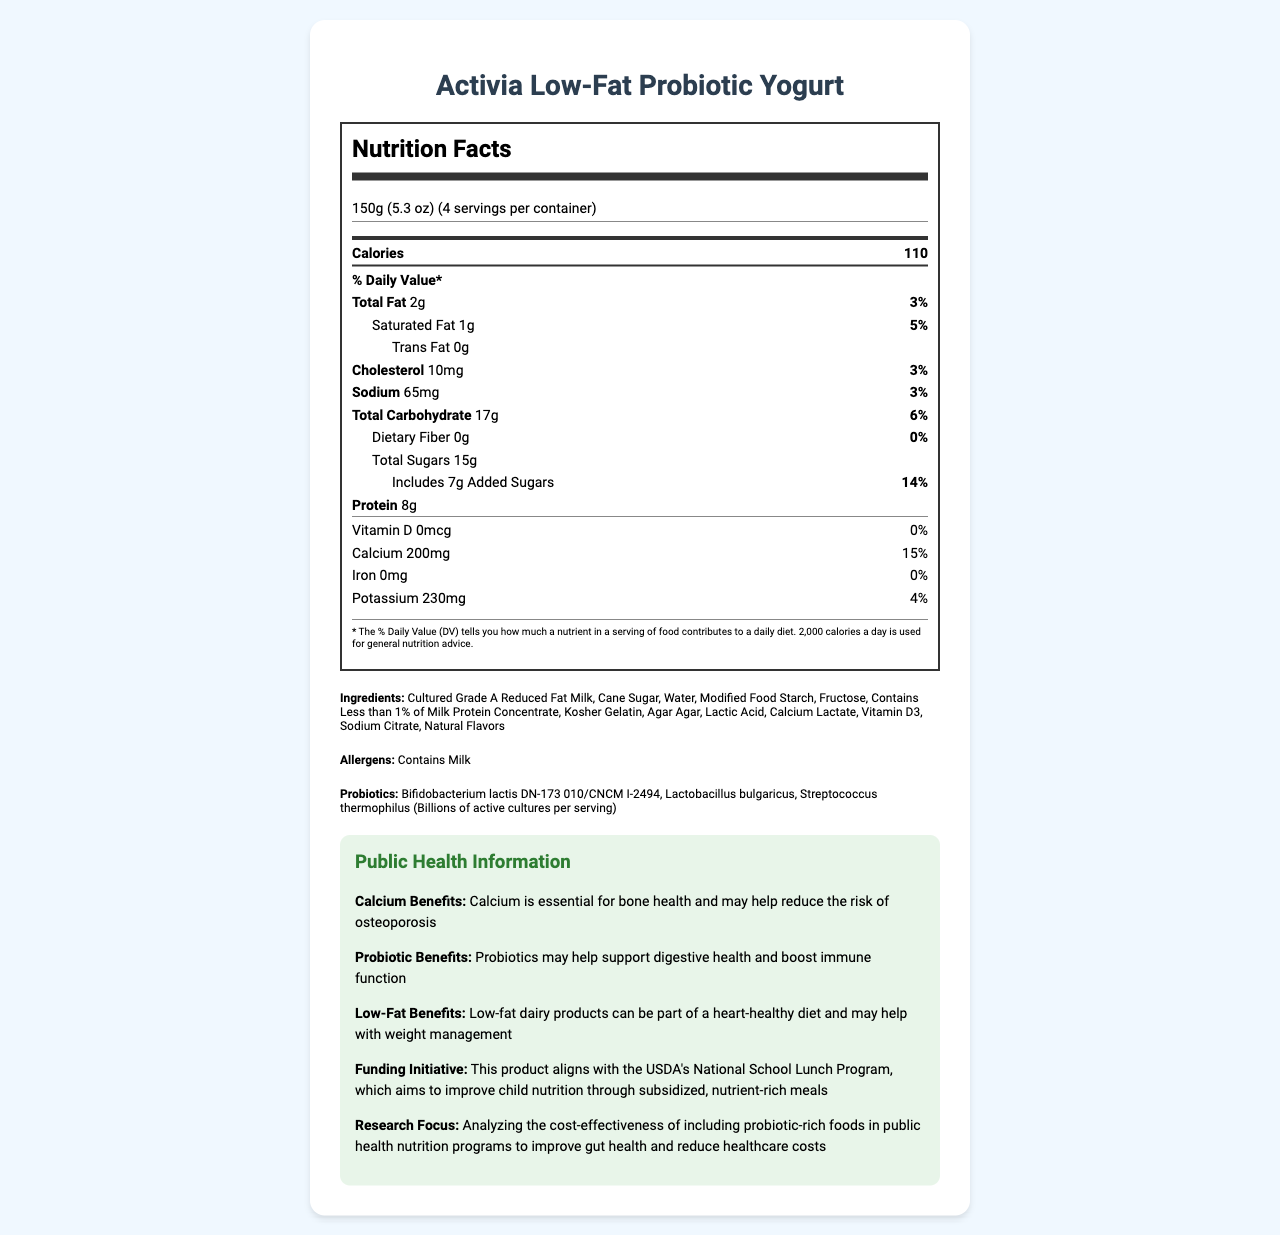what is the serving size for Activia Low-Fat Probiotic Yogurt? The serving size is explicitly mentioned under the serving information at the top of the document.
Answer: 150g (5.3 oz) how many servings are there per container? The document states that there are 4 servings per container at the top under the product name.
Answer: 4 how much calcium is there in a serving of the yogurt? The calcium content is found in the nutrient table under the “Calcium” row.
Answer: 200mg what percentage of the daily value is the added sugars? The percentage of added sugars is listed in the nutrient table under “Includes 7g Added Sugars.”
Answer: 14% list the probiotics contained in this yogurt. These strains are listed under the "Ingredients" section of the document.
Answer: Bifidobacterium lactis DN-173 010/CNCM I-2494, Lactobacillus bulgaricus, Streptococcus thermophilus which of the following best describes the primary health benefits of the probiotics in the yogurt? A. Improve bone health B. Support digestive health C. Enhance muscle growth The document states that probiotics may help support digestive health and boost immune function.
Answer: B how many calories are in a single serving? A. 90 B. 110 C. 120 D. 130 The calories in a single serving are clearly listed as 110 in the nutrient table.
Answer: B is there any iron in this yogurt? The document states that both the iron amount and the percent daily value are 0%.
Answer: No summarize the main points of the document. The document includes detailed nutrition information, a list of ingredients and allergens, and public health benefits related to calcium, low fat, and probiotics. Additionally, it contains information on a funding initiative and research focus.
Answer: This document provides the nutrition facts for Activia Low-Fat Probiotic Yogurt, emphasizing its low fat and probiotic content. The yogurt contains key nutrients such as protein and calcium, along with beneficial probiotics. It also aligns with public health initiatives like the USDA's National School Lunch Program and aims to promote digestive health while being a heart-healthy, low-fat option. what is the total amount of sugars in a single serving of the yogurt? The total amount of sugars is listed as 15g in the nutrient table under “Total Sugars.”
Answer: 15g how many grams of protein does each serving of yogurt contain? The protein content per serving is listed as 8g in the nutrient table.
Answer: 8g what is the research focus related to this product? The research focus is explicitly mentioned under the public health information section.
Answer: Analyzing the cost-effectiveness of including probiotic-rich foods in public health nutrition programs to improve gut health and reduce healthcare costs. can this document tell you the cost of Activia Low-Fat Probiotic Yogurt? The document does not provide any pricing information. It focuses solely on the nutritional content and public health information.
Answer: Not enough information which of the following nutrients contribute 3% of the daily value per serving? A. Total Fat B. Cholesterol C. Sodium D. All of the above Both total fat and cholesterol contribute 3%, and sodium also contributes 3% of the daily value per serving.
Answer: D what are the benefits of including calcium in the diet according to this document? This information is found in the public health information section under “Calcium Benefits.”
Answer: Calcium is essential for bone health and may help reduce the risk of osteoporosis. 